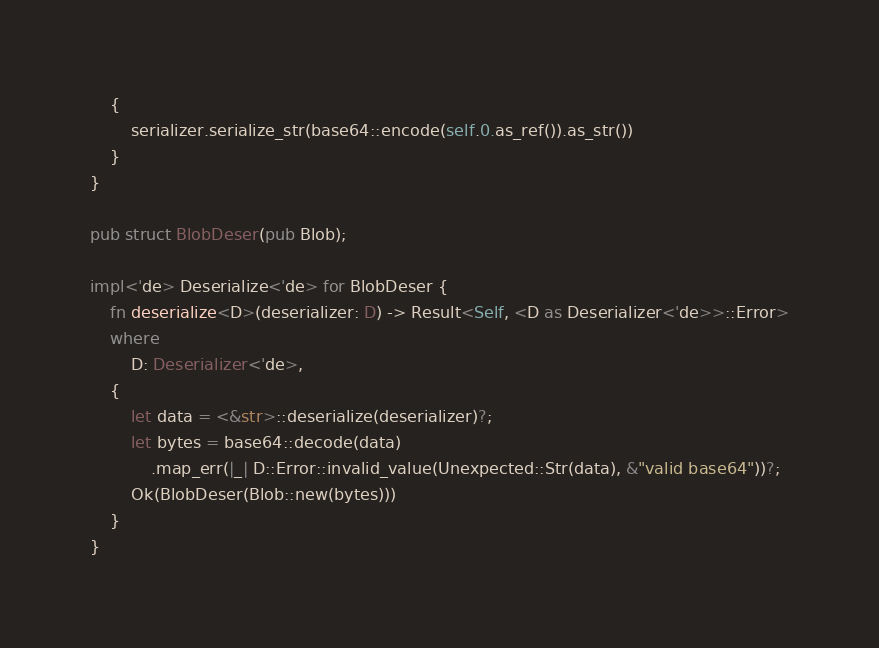<code> <loc_0><loc_0><loc_500><loc_500><_Rust_>    {
        serializer.serialize_str(base64::encode(self.0.as_ref()).as_str())
    }
}

pub struct BlobDeser(pub Blob);

impl<'de> Deserialize<'de> for BlobDeser {
    fn deserialize<D>(deserializer: D) -> Result<Self, <D as Deserializer<'de>>::Error>
    where
        D: Deserializer<'de>,
    {
        let data = <&str>::deserialize(deserializer)?;
        let bytes = base64::decode(data)
            .map_err(|_| D::Error::invalid_value(Unexpected::Str(data), &"valid base64"))?;
        Ok(BlobDeser(Blob::new(bytes)))
    }
}
</code> 